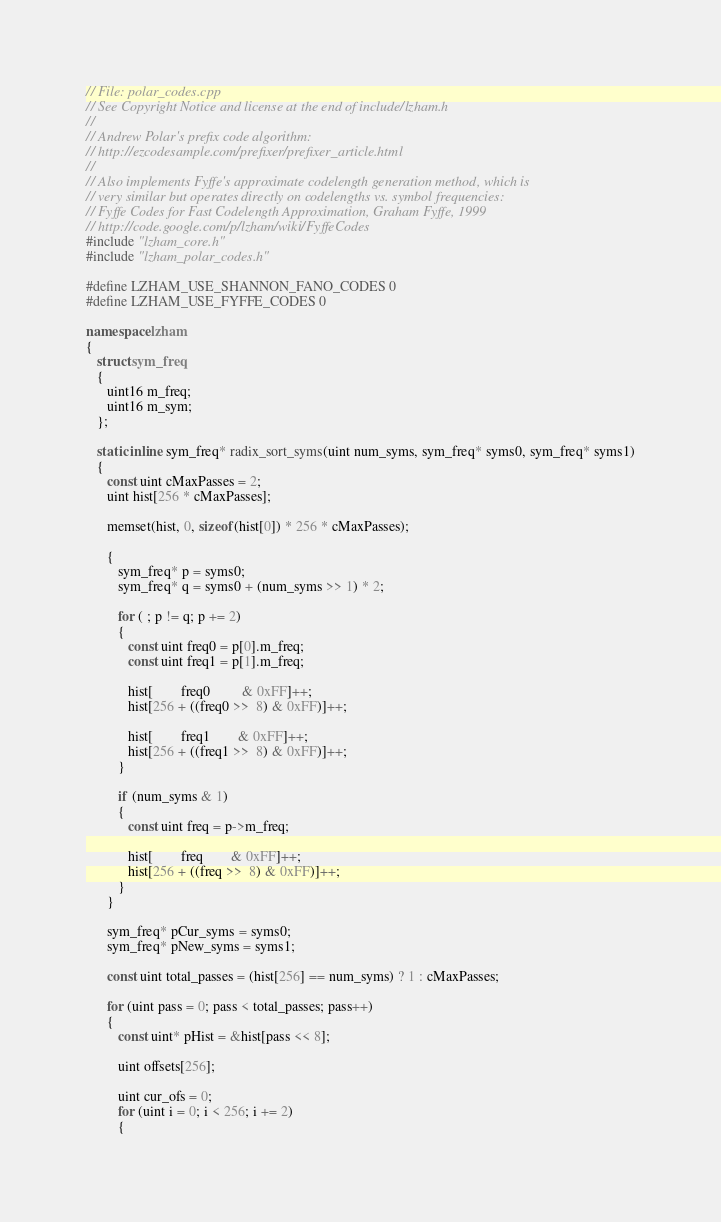Convert code to text. <code><loc_0><loc_0><loc_500><loc_500><_C++_>// File: polar_codes.cpp
// See Copyright Notice and license at the end of include/lzham.h
//
// Andrew Polar's prefix code algorithm: 
// http://ezcodesample.com/prefixer/prefixer_article.html
//
// Also implements Fyffe's approximate codelength generation method, which is
// very similar but operates directly on codelengths vs. symbol frequencies:
// Fyffe Codes for Fast Codelength Approximation, Graham Fyffe, 1999
// http://code.google.com/p/lzham/wiki/FyffeCodes
#include "lzham_core.h"
#include "lzham_polar_codes.h"

#define LZHAM_USE_SHANNON_FANO_CODES 0
#define LZHAM_USE_FYFFE_CODES 0

namespace lzham
{
   struct sym_freq
   {
      uint16 m_freq;
      uint16 m_sym;
   };

   static inline sym_freq* radix_sort_syms(uint num_syms, sym_freq* syms0, sym_freq* syms1)
   {  
      const uint cMaxPasses = 2;
      uint hist[256 * cMaxPasses];

      memset(hist, 0, sizeof(hist[0]) * 256 * cMaxPasses);
      
      {
         sym_freq* p = syms0;
         sym_freq* q = syms0 + (num_syms >> 1) * 2;

         for ( ; p != q; p += 2)
         {
            const uint freq0 = p[0].m_freq;
            const uint freq1 = p[1].m_freq;

            hist[        freq0         & 0xFF]++;
            hist[256 + ((freq0 >>  8) & 0xFF)]++;

            hist[        freq1        & 0xFF]++;
            hist[256 + ((freq1 >>  8) & 0xFF)]++;
         }

         if (num_syms & 1)
         {
            const uint freq = p->m_freq;

            hist[        freq        & 0xFF]++;
            hist[256 + ((freq >>  8) & 0xFF)]++;
         }
      }

      sym_freq* pCur_syms = syms0;
      sym_freq* pNew_syms = syms1;
      
      const uint total_passes = (hist[256] == num_syms) ? 1 : cMaxPasses;
               
      for (uint pass = 0; pass < total_passes; pass++)
      {
         const uint* pHist = &hist[pass << 8];

         uint offsets[256];

         uint cur_ofs = 0;
         for (uint i = 0; i < 256; i += 2)
         {</code> 